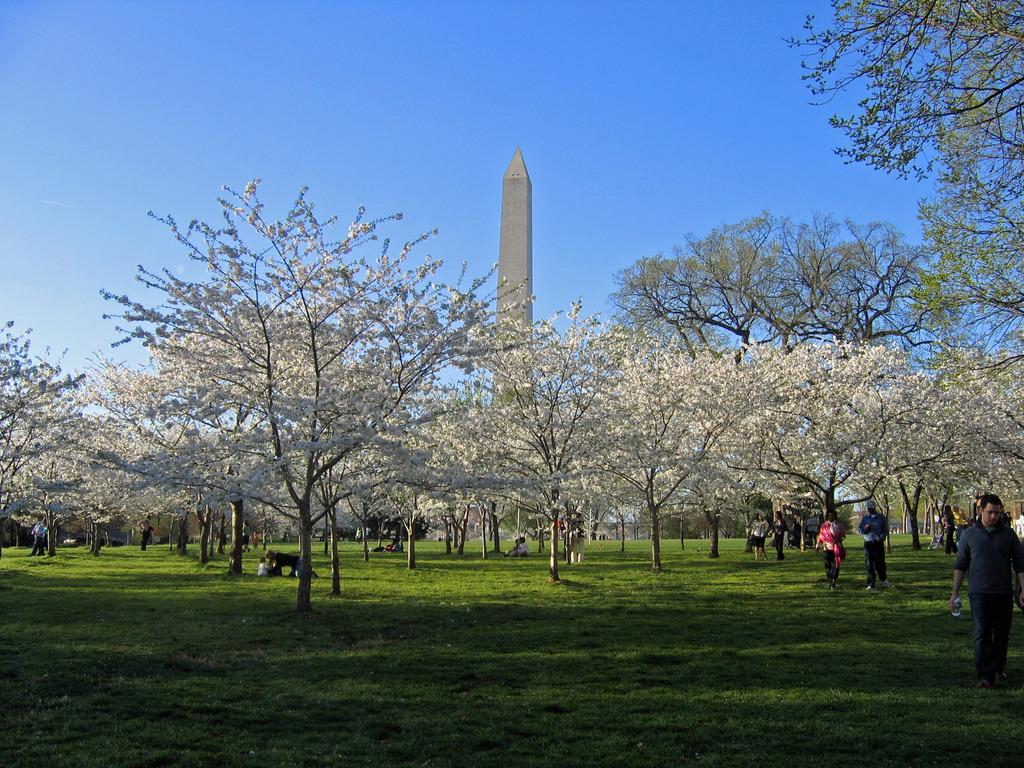Who or what is present in the image? There are people in the image. Where are the people located? The people are on the grass. What else can be seen in the image besides the people? There are trees and a building in the image. How do the people start the car in the image? There is no car present in the image, so the people cannot start a car. 